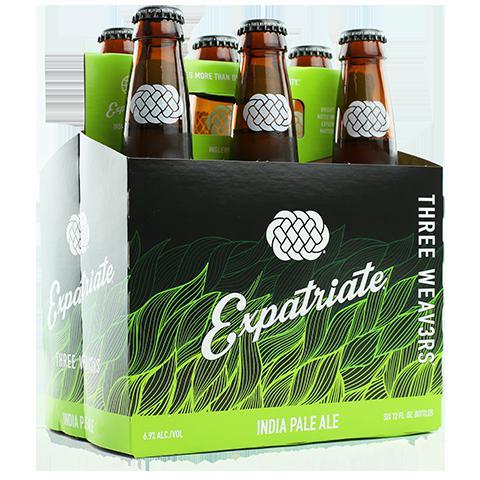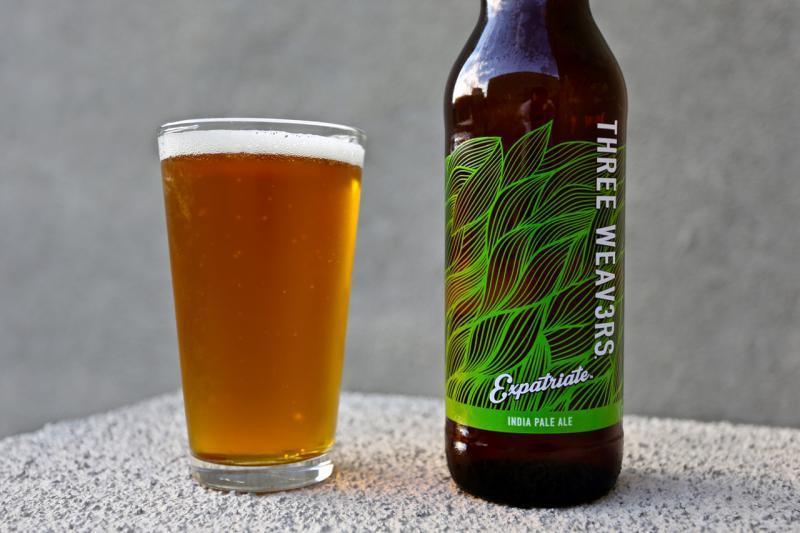The first image is the image on the left, the second image is the image on the right. Evaluate the accuracy of this statement regarding the images: "In one image, bottles of ale fill the shelf of a cooler.". Is it true? Answer yes or no. No. The first image is the image on the left, the second image is the image on the right. Assess this claim about the two images: "There are no more than six bottles in the image on the left". Correct or not? Answer yes or no. Yes. 